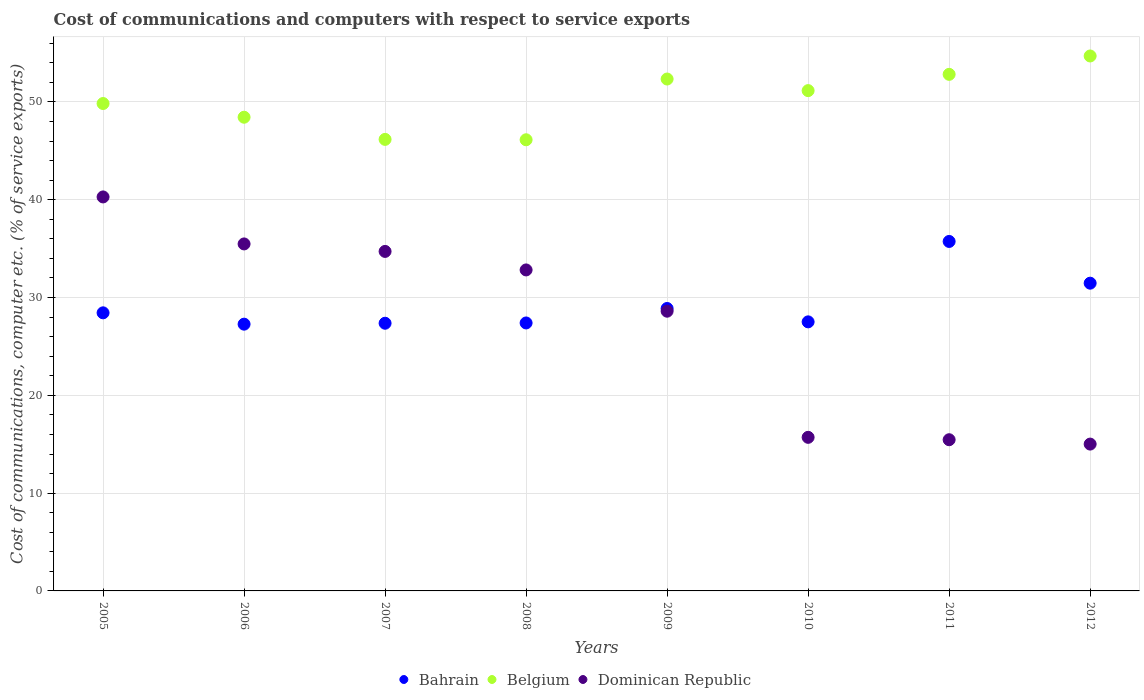How many different coloured dotlines are there?
Keep it short and to the point. 3. Is the number of dotlines equal to the number of legend labels?
Provide a succinct answer. Yes. What is the cost of communications and computers in Belgium in 2009?
Your answer should be very brief. 52.34. Across all years, what is the maximum cost of communications and computers in Bahrain?
Provide a succinct answer. 35.73. Across all years, what is the minimum cost of communications and computers in Dominican Republic?
Give a very brief answer. 15.01. What is the total cost of communications and computers in Bahrain in the graph?
Offer a terse response. 234.07. What is the difference between the cost of communications and computers in Belgium in 2007 and that in 2011?
Keep it short and to the point. -6.65. What is the difference between the cost of communications and computers in Bahrain in 2005 and the cost of communications and computers in Belgium in 2008?
Give a very brief answer. -17.7. What is the average cost of communications and computers in Belgium per year?
Offer a very short reply. 50.2. In the year 2007, what is the difference between the cost of communications and computers in Dominican Republic and cost of communications and computers in Bahrain?
Offer a very short reply. 7.34. What is the ratio of the cost of communications and computers in Bahrain in 2009 to that in 2010?
Offer a very short reply. 1.05. Is the difference between the cost of communications and computers in Dominican Republic in 2006 and 2008 greater than the difference between the cost of communications and computers in Bahrain in 2006 and 2008?
Your answer should be very brief. Yes. What is the difference between the highest and the second highest cost of communications and computers in Bahrain?
Your response must be concise. 4.27. What is the difference between the highest and the lowest cost of communications and computers in Belgium?
Ensure brevity in your answer.  8.57. In how many years, is the cost of communications and computers in Bahrain greater than the average cost of communications and computers in Bahrain taken over all years?
Provide a short and direct response. 2. Does the cost of communications and computers in Dominican Republic monotonically increase over the years?
Offer a very short reply. No. Is the cost of communications and computers in Bahrain strictly greater than the cost of communications and computers in Dominican Republic over the years?
Make the answer very short. No. How many years are there in the graph?
Give a very brief answer. 8. What is the difference between two consecutive major ticks on the Y-axis?
Offer a terse response. 10. Are the values on the major ticks of Y-axis written in scientific E-notation?
Your answer should be very brief. No. Does the graph contain any zero values?
Make the answer very short. No. Where does the legend appear in the graph?
Provide a short and direct response. Bottom center. How are the legend labels stacked?
Your answer should be very brief. Horizontal. What is the title of the graph?
Provide a succinct answer. Cost of communications and computers with respect to service exports. What is the label or title of the X-axis?
Offer a terse response. Years. What is the label or title of the Y-axis?
Offer a very short reply. Cost of communications, computer etc. (% of service exports). What is the Cost of communications, computer etc. (% of service exports) in Bahrain in 2005?
Give a very brief answer. 28.43. What is the Cost of communications, computer etc. (% of service exports) of Belgium in 2005?
Give a very brief answer. 49.84. What is the Cost of communications, computer etc. (% of service exports) in Dominican Republic in 2005?
Give a very brief answer. 40.28. What is the Cost of communications, computer etc. (% of service exports) in Bahrain in 2006?
Offer a terse response. 27.28. What is the Cost of communications, computer etc. (% of service exports) of Belgium in 2006?
Your answer should be very brief. 48.43. What is the Cost of communications, computer etc. (% of service exports) in Dominican Republic in 2006?
Ensure brevity in your answer.  35.48. What is the Cost of communications, computer etc. (% of service exports) of Bahrain in 2007?
Make the answer very short. 27.37. What is the Cost of communications, computer etc. (% of service exports) in Belgium in 2007?
Your answer should be compact. 46.17. What is the Cost of communications, computer etc. (% of service exports) of Dominican Republic in 2007?
Offer a very short reply. 34.71. What is the Cost of communications, computer etc. (% of service exports) of Bahrain in 2008?
Give a very brief answer. 27.4. What is the Cost of communications, computer etc. (% of service exports) in Belgium in 2008?
Offer a very short reply. 46.13. What is the Cost of communications, computer etc. (% of service exports) of Dominican Republic in 2008?
Give a very brief answer. 32.82. What is the Cost of communications, computer etc. (% of service exports) in Bahrain in 2009?
Provide a succinct answer. 28.88. What is the Cost of communications, computer etc. (% of service exports) in Belgium in 2009?
Your answer should be compact. 52.34. What is the Cost of communications, computer etc. (% of service exports) in Dominican Republic in 2009?
Give a very brief answer. 28.6. What is the Cost of communications, computer etc. (% of service exports) of Bahrain in 2010?
Provide a short and direct response. 27.51. What is the Cost of communications, computer etc. (% of service exports) of Belgium in 2010?
Ensure brevity in your answer.  51.16. What is the Cost of communications, computer etc. (% of service exports) in Dominican Republic in 2010?
Offer a very short reply. 15.7. What is the Cost of communications, computer etc. (% of service exports) of Bahrain in 2011?
Your answer should be very brief. 35.73. What is the Cost of communications, computer etc. (% of service exports) of Belgium in 2011?
Provide a short and direct response. 52.82. What is the Cost of communications, computer etc. (% of service exports) of Dominican Republic in 2011?
Give a very brief answer. 15.46. What is the Cost of communications, computer etc. (% of service exports) in Bahrain in 2012?
Offer a very short reply. 31.47. What is the Cost of communications, computer etc. (% of service exports) in Belgium in 2012?
Give a very brief answer. 54.7. What is the Cost of communications, computer etc. (% of service exports) in Dominican Republic in 2012?
Your response must be concise. 15.01. Across all years, what is the maximum Cost of communications, computer etc. (% of service exports) in Bahrain?
Offer a terse response. 35.73. Across all years, what is the maximum Cost of communications, computer etc. (% of service exports) of Belgium?
Offer a terse response. 54.7. Across all years, what is the maximum Cost of communications, computer etc. (% of service exports) of Dominican Republic?
Provide a short and direct response. 40.28. Across all years, what is the minimum Cost of communications, computer etc. (% of service exports) in Bahrain?
Make the answer very short. 27.28. Across all years, what is the minimum Cost of communications, computer etc. (% of service exports) in Belgium?
Offer a very short reply. 46.13. Across all years, what is the minimum Cost of communications, computer etc. (% of service exports) in Dominican Republic?
Your answer should be very brief. 15.01. What is the total Cost of communications, computer etc. (% of service exports) in Bahrain in the graph?
Provide a short and direct response. 234.07. What is the total Cost of communications, computer etc. (% of service exports) of Belgium in the graph?
Provide a short and direct response. 401.58. What is the total Cost of communications, computer etc. (% of service exports) of Dominican Republic in the graph?
Your answer should be compact. 218.08. What is the difference between the Cost of communications, computer etc. (% of service exports) of Bahrain in 2005 and that in 2006?
Provide a succinct answer. 1.16. What is the difference between the Cost of communications, computer etc. (% of service exports) of Belgium in 2005 and that in 2006?
Ensure brevity in your answer.  1.4. What is the difference between the Cost of communications, computer etc. (% of service exports) of Dominican Republic in 2005 and that in 2006?
Provide a succinct answer. 4.81. What is the difference between the Cost of communications, computer etc. (% of service exports) in Bahrain in 2005 and that in 2007?
Give a very brief answer. 1.06. What is the difference between the Cost of communications, computer etc. (% of service exports) of Belgium in 2005 and that in 2007?
Your answer should be compact. 3.67. What is the difference between the Cost of communications, computer etc. (% of service exports) in Dominican Republic in 2005 and that in 2007?
Your answer should be compact. 5.57. What is the difference between the Cost of communications, computer etc. (% of service exports) of Bahrain in 2005 and that in 2008?
Keep it short and to the point. 1.03. What is the difference between the Cost of communications, computer etc. (% of service exports) in Belgium in 2005 and that in 2008?
Provide a succinct answer. 3.71. What is the difference between the Cost of communications, computer etc. (% of service exports) of Dominican Republic in 2005 and that in 2008?
Provide a short and direct response. 7.46. What is the difference between the Cost of communications, computer etc. (% of service exports) in Bahrain in 2005 and that in 2009?
Make the answer very short. -0.44. What is the difference between the Cost of communications, computer etc. (% of service exports) of Belgium in 2005 and that in 2009?
Give a very brief answer. -2.5. What is the difference between the Cost of communications, computer etc. (% of service exports) of Dominican Republic in 2005 and that in 2009?
Offer a very short reply. 11.68. What is the difference between the Cost of communications, computer etc. (% of service exports) in Bahrain in 2005 and that in 2010?
Your response must be concise. 0.92. What is the difference between the Cost of communications, computer etc. (% of service exports) of Belgium in 2005 and that in 2010?
Provide a succinct answer. -1.32. What is the difference between the Cost of communications, computer etc. (% of service exports) in Dominican Republic in 2005 and that in 2010?
Provide a short and direct response. 24.58. What is the difference between the Cost of communications, computer etc. (% of service exports) in Bahrain in 2005 and that in 2011?
Provide a succinct answer. -7.3. What is the difference between the Cost of communications, computer etc. (% of service exports) in Belgium in 2005 and that in 2011?
Provide a succinct answer. -2.98. What is the difference between the Cost of communications, computer etc. (% of service exports) of Dominican Republic in 2005 and that in 2011?
Your answer should be compact. 24.82. What is the difference between the Cost of communications, computer etc. (% of service exports) of Bahrain in 2005 and that in 2012?
Keep it short and to the point. -3.03. What is the difference between the Cost of communications, computer etc. (% of service exports) in Belgium in 2005 and that in 2012?
Offer a very short reply. -4.86. What is the difference between the Cost of communications, computer etc. (% of service exports) of Dominican Republic in 2005 and that in 2012?
Offer a very short reply. 25.27. What is the difference between the Cost of communications, computer etc. (% of service exports) in Bahrain in 2006 and that in 2007?
Provide a short and direct response. -0.09. What is the difference between the Cost of communications, computer etc. (% of service exports) in Belgium in 2006 and that in 2007?
Your answer should be very brief. 2.27. What is the difference between the Cost of communications, computer etc. (% of service exports) in Dominican Republic in 2006 and that in 2007?
Keep it short and to the point. 0.77. What is the difference between the Cost of communications, computer etc. (% of service exports) of Bahrain in 2006 and that in 2008?
Your answer should be very brief. -0.12. What is the difference between the Cost of communications, computer etc. (% of service exports) in Belgium in 2006 and that in 2008?
Keep it short and to the point. 2.3. What is the difference between the Cost of communications, computer etc. (% of service exports) in Dominican Republic in 2006 and that in 2008?
Offer a terse response. 2.66. What is the difference between the Cost of communications, computer etc. (% of service exports) in Bahrain in 2006 and that in 2009?
Keep it short and to the point. -1.6. What is the difference between the Cost of communications, computer etc. (% of service exports) in Belgium in 2006 and that in 2009?
Give a very brief answer. -3.91. What is the difference between the Cost of communications, computer etc. (% of service exports) in Dominican Republic in 2006 and that in 2009?
Your response must be concise. 6.88. What is the difference between the Cost of communications, computer etc. (% of service exports) in Bahrain in 2006 and that in 2010?
Offer a terse response. -0.24. What is the difference between the Cost of communications, computer etc. (% of service exports) in Belgium in 2006 and that in 2010?
Give a very brief answer. -2.72. What is the difference between the Cost of communications, computer etc. (% of service exports) of Dominican Republic in 2006 and that in 2010?
Provide a succinct answer. 19.78. What is the difference between the Cost of communications, computer etc. (% of service exports) of Bahrain in 2006 and that in 2011?
Give a very brief answer. -8.46. What is the difference between the Cost of communications, computer etc. (% of service exports) of Belgium in 2006 and that in 2011?
Offer a terse response. -4.38. What is the difference between the Cost of communications, computer etc. (% of service exports) in Dominican Republic in 2006 and that in 2011?
Your answer should be compact. 20.02. What is the difference between the Cost of communications, computer etc. (% of service exports) in Bahrain in 2006 and that in 2012?
Your answer should be very brief. -4.19. What is the difference between the Cost of communications, computer etc. (% of service exports) in Belgium in 2006 and that in 2012?
Offer a very short reply. -6.26. What is the difference between the Cost of communications, computer etc. (% of service exports) in Dominican Republic in 2006 and that in 2012?
Provide a succinct answer. 20.47. What is the difference between the Cost of communications, computer etc. (% of service exports) of Bahrain in 2007 and that in 2008?
Provide a short and direct response. -0.03. What is the difference between the Cost of communications, computer etc. (% of service exports) in Belgium in 2007 and that in 2008?
Give a very brief answer. 0.04. What is the difference between the Cost of communications, computer etc. (% of service exports) of Dominican Republic in 2007 and that in 2008?
Provide a succinct answer. 1.89. What is the difference between the Cost of communications, computer etc. (% of service exports) of Bahrain in 2007 and that in 2009?
Make the answer very short. -1.51. What is the difference between the Cost of communications, computer etc. (% of service exports) in Belgium in 2007 and that in 2009?
Give a very brief answer. -6.17. What is the difference between the Cost of communications, computer etc. (% of service exports) in Dominican Republic in 2007 and that in 2009?
Provide a succinct answer. 6.11. What is the difference between the Cost of communications, computer etc. (% of service exports) in Bahrain in 2007 and that in 2010?
Make the answer very short. -0.14. What is the difference between the Cost of communications, computer etc. (% of service exports) of Belgium in 2007 and that in 2010?
Ensure brevity in your answer.  -4.99. What is the difference between the Cost of communications, computer etc. (% of service exports) of Dominican Republic in 2007 and that in 2010?
Offer a terse response. 19.01. What is the difference between the Cost of communications, computer etc. (% of service exports) of Bahrain in 2007 and that in 2011?
Your answer should be compact. -8.36. What is the difference between the Cost of communications, computer etc. (% of service exports) in Belgium in 2007 and that in 2011?
Keep it short and to the point. -6.65. What is the difference between the Cost of communications, computer etc. (% of service exports) of Dominican Republic in 2007 and that in 2011?
Offer a very short reply. 19.25. What is the difference between the Cost of communications, computer etc. (% of service exports) of Bahrain in 2007 and that in 2012?
Provide a succinct answer. -4.1. What is the difference between the Cost of communications, computer etc. (% of service exports) of Belgium in 2007 and that in 2012?
Provide a short and direct response. -8.53. What is the difference between the Cost of communications, computer etc. (% of service exports) of Dominican Republic in 2007 and that in 2012?
Ensure brevity in your answer.  19.7. What is the difference between the Cost of communications, computer etc. (% of service exports) of Bahrain in 2008 and that in 2009?
Your answer should be compact. -1.48. What is the difference between the Cost of communications, computer etc. (% of service exports) of Belgium in 2008 and that in 2009?
Ensure brevity in your answer.  -6.21. What is the difference between the Cost of communications, computer etc. (% of service exports) in Dominican Republic in 2008 and that in 2009?
Provide a succinct answer. 4.22. What is the difference between the Cost of communications, computer etc. (% of service exports) of Bahrain in 2008 and that in 2010?
Make the answer very short. -0.11. What is the difference between the Cost of communications, computer etc. (% of service exports) of Belgium in 2008 and that in 2010?
Provide a succinct answer. -5.03. What is the difference between the Cost of communications, computer etc. (% of service exports) in Dominican Republic in 2008 and that in 2010?
Your answer should be compact. 17.12. What is the difference between the Cost of communications, computer etc. (% of service exports) in Bahrain in 2008 and that in 2011?
Your answer should be very brief. -8.33. What is the difference between the Cost of communications, computer etc. (% of service exports) of Belgium in 2008 and that in 2011?
Keep it short and to the point. -6.69. What is the difference between the Cost of communications, computer etc. (% of service exports) in Dominican Republic in 2008 and that in 2011?
Your answer should be very brief. 17.36. What is the difference between the Cost of communications, computer etc. (% of service exports) of Bahrain in 2008 and that in 2012?
Your answer should be very brief. -4.07. What is the difference between the Cost of communications, computer etc. (% of service exports) in Belgium in 2008 and that in 2012?
Provide a succinct answer. -8.57. What is the difference between the Cost of communications, computer etc. (% of service exports) of Dominican Republic in 2008 and that in 2012?
Make the answer very short. 17.81. What is the difference between the Cost of communications, computer etc. (% of service exports) in Bahrain in 2009 and that in 2010?
Provide a short and direct response. 1.37. What is the difference between the Cost of communications, computer etc. (% of service exports) of Belgium in 2009 and that in 2010?
Your response must be concise. 1.19. What is the difference between the Cost of communications, computer etc. (% of service exports) of Dominican Republic in 2009 and that in 2010?
Keep it short and to the point. 12.9. What is the difference between the Cost of communications, computer etc. (% of service exports) of Bahrain in 2009 and that in 2011?
Keep it short and to the point. -6.85. What is the difference between the Cost of communications, computer etc. (% of service exports) of Belgium in 2009 and that in 2011?
Your response must be concise. -0.48. What is the difference between the Cost of communications, computer etc. (% of service exports) of Dominican Republic in 2009 and that in 2011?
Keep it short and to the point. 13.14. What is the difference between the Cost of communications, computer etc. (% of service exports) in Bahrain in 2009 and that in 2012?
Offer a very short reply. -2.59. What is the difference between the Cost of communications, computer etc. (% of service exports) in Belgium in 2009 and that in 2012?
Offer a terse response. -2.36. What is the difference between the Cost of communications, computer etc. (% of service exports) of Dominican Republic in 2009 and that in 2012?
Give a very brief answer. 13.59. What is the difference between the Cost of communications, computer etc. (% of service exports) in Bahrain in 2010 and that in 2011?
Give a very brief answer. -8.22. What is the difference between the Cost of communications, computer etc. (% of service exports) of Belgium in 2010 and that in 2011?
Ensure brevity in your answer.  -1.66. What is the difference between the Cost of communications, computer etc. (% of service exports) of Dominican Republic in 2010 and that in 2011?
Your response must be concise. 0.24. What is the difference between the Cost of communications, computer etc. (% of service exports) of Bahrain in 2010 and that in 2012?
Provide a succinct answer. -3.95. What is the difference between the Cost of communications, computer etc. (% of service exports) in Belgium in 2010 and that in 2012?
Keep it short and to the point. -3.54. What is the difference between the Cost of communications, computer etc. (% of service exports) in Dominican Republic in 2010 and that in 2012?
Provide a short and direct response. 0.69. What is the difference between the Cost of communications, computer etc. (% of service exports) of Bahrain in 2011 and that in 2012?
Make the answer very short. 4.27. What is the difference between the Cost of communications, computer etc. (% of service exports) of Belgium in 2011 and that in 2012?
Make the answer very short. -1.88. What is the difference between the Cost of communications, computer etc. (% of service exports) in Dominican Republic in 2011 and that in 2012?
Keep it short and to the point. 0.45. What is the difference between the Cost of communications, computer etc. (% of service exports) of Bahrain in 2005 and the Cost of communications, computer etc. (% of service exports) of Belgium in 2006?
Offer a terse response. -20. What is the difference between the Cost of communications, computer etc. (% of service exports) of Bahrain in 2005 and the Cost of communications, computer etc. (% of service exports) of Dominican Republic in 2006?
Your answer should be compact. -7.05. What is the difference between the Cost of communications, computer etc. (% of service exports) in Belgium in 2005 and the Cost of communications, computer etc. (% of service exports) in Dominican Republic in 2006?
Provide a succinct answer. 14.36. What is the difference between the Cost of communications, computer etc. (% of service exports) of Bahrain in 2005 and the Cost of communications, computer etc. (% of service exports) of Belgium in 2007?
Your response must be concise. -17.73. What is the difference between the Cost of communications, computer etc. (% of service exports) of Bahrain in 2005 and the Cost of communications, computer etc. (% of service exports) of Dominican Republic in 2007?
Your answer should be compact. -6.28. What is the difference between the Cost of communications, computer etc. (% of service exports) in Belgium in 2005 and the Cost of communications, computer etc. (% of service exports) in Dominican Republic in 2007?
Make the answer very short. 15.12. What is the difference between the Cost of communications, computer etc. (% of service exports) of Bahrain in 2005 and the Cost of communications, computer etc. (% of service exports) of Belgium in 2008?
Provide a short and direct response. -17.7. What is the difference between the Cost of communications, computer etc. (% of service exports) of Bahrain in 2005 and the Cost of communications, computer etc. (% of service exports) of Dominican Republic in 2008?
Your response must be concise. -4.39. What is the difference between the Cost of communications, computer etc. (% of service exports) of Belgium in 2005 and the Cost of communications, computer etc. (% of service exports) of Dominican Republic in 2008?
Your answer should be very brief. 17.02. What is the difference between the Cost of communications, computer etc. (% of service exports) in Bahrain in 2005 and the Cost of communications, computer etc. (% of service exports) in Belgium in 2009?
Keep it short and to the point. -23.91. What is the difference between the Cost of communications, computer etc. (% of service exports) in Bahrain in 2005 and the Cost of communications, computer etc. (% of service exports) in Dominican Republic in 2009?
Ensure brevity in your answer.  -0.17. What is the difference between the Cost of communications, computer etc. (% of service exports) of Belgium in 2005 and the Cost of communications, computer etc. (% of service exports) of Dominican Republic in 2009?
Offer a terse response. 21.24. What is the difference between the Cost of communications, computer etc. (% of service exports) in Bahrain in 2005 and the Cost of communications, computer etc. (% of service exports) in Belgium in 2010?
Make the answer very short. -22.72. What is the difference between the Cost of communications, computer etc. (% of service exports) in Bahrain in 2005 and the Cost of communications, computer etc. (% of service exports) in Dominican Republic in 2010?
Ensure brevity in your answer.  12.73. What is the difference between the Cost of communications, computer etc. (% of service exports) of Belgium in 2005 and the Cost of communications, computer etc. (% of service exports) of Dominican Republic in 2010?
Your response must be concise. 34.13. What is the difference between the Cost of communications, computer etc. (% of service exports) of Bahrain in 2005 and the Cost of communications, computer etc. (% of service exports) of Belgium in 2011?
Offer a terse response. -24.38. What is the difference between the Cost of communications, computer etc. (% of service exports) in Bahrain in 2005 and the Cost of communications, computer etc. (% of service exports) in Dominican Republic in 2011?
Provide a succinct answer. 12.97. What is the difference between the Cost of communications, computer etc. (% of service exports) of Belgium in 2005 and the Cost of communications, computer etc. (% of service exports) of Dominican Republic in 2011?
Make the answer very short. 34.38. What is the difference between the Cost of communications, computer etc. (% of service exports) in Bahrain in 2005 and the Cost of communications, computer etc. (% of service exports) in Belgium in 2012?
Keep it short and to the point. -26.26. What is the difference between the Cost of communications, computer etc. (% of service exports) in Bahrain in 2005 and the Cost of communications, computer etc. (% of service exports) in Dominican Republic in 2012?
Your answer should be compact. 13.42. What is the difference between the Cost of communications, computer etc. (% of service exports) in Belgium in 2005 and the Cost of communications, computer etc. (% of service exports) in Dominican Republic in 2012?
Give a very brief answer. 34.82. What is the difference between the Cost of communications, computer etc. (% of service exports) of Bahrain in 2006 and the Cost of communications, computer etc. (% of service exports) of Belgium in 2007?
Provide a succinct answer. -18.89. What is the difference between the Cost of communications, computer etc. (% of service exports) in Bahrain in 2006 and the Cost of communications, computer etc. (% of service exports) in Dominican Republic in 2007?
Make the answer very short. -7.44. What is the difference between the Cost of communications, computer etc. (% of service exports) of Belgium in 2006 and the Cost of communications, computer etc. (% of service exports) of Dominican Republic in 2007?
Provide a succinct answer. 13.72. What is the difference between the Cost of communications, computer etc. (% of service exports) in Bahrain in 2006 and the Cost of communications, computer etc. (% of service exports) in Belgium in 2008?
Offer a very short reply. -18.85. What is the difference between the Cost of communications, computer etc. (% of service exports) of Bahrain in 2006 and the Cost of communications, computer etc. (% of service exports) of Dominican Republic in 2008?
Your answer should be compact. -5.55. What is the difference between the Cost of communications, computer etc. (% of service exports) in Belgium in 2006 and the Cost of communications, computer etc. (% of service exports) in Dominican Republic in 2008?
Your answer should be very brief. 15.61. What is the difference between the Cost of communications, computer etc. (% of service exports) in Bahrain in 2006 and the Cost of communications, computer etc. (% of service exports) in Belgium in 2009?
Give a very brief answer. -25.07. What is the difference between the Cost of communications, computer etc. (% of service exports) of Bahrain in 2006 and the Cost of communications, computer etc. (% of service exports) of Dominican Republic in 2009?
Ensure brevity in your answer.  -1.33. What is the difference between the Cost of communications, computer etc. (% of service exports) in Belgium in 2006 and the Cost of communications, computer etc. (% of service exports) in Dominican Republic in 2009?
Make the answer very short. 19.83. What is the difference between the Cost of communications, computer etc. (% of service exports) of Bahrain in 2006 and the Cost of communications, computer etc. (% of service exports) of Belgium in 2010?
Offer a terse response. -23.88. What is the difference between the Cost of communications, computer etc. (% of service exports) of Bahrain in 2006 and the Cost of communications, computer etc. (% of service exports) of Dominican Republic in 2010?
Provide a short and direct response. 11.57. What is the difference between the Cost of communications, computer etc. (% of service exports) of Belgium in 2006 and the Cost of communications, computer etc. (% of service exports) of Dominican Republic in 2010?
Your answer should be very brief. 32.73. What is the difference between the Cost of communications, computer etc. (% of service exports) in Bahrain in 2006 and the Cost of communications, computer etc. (% of service exports) in Belgium in 2011?
Keep it short and to the point. -25.54. What is the difference between the Cost of communications, computer etc. (% of service exports) of Bahrain in 2006 and the Cost of communications, computer etc. (% of service exports) of Dominican Republic in 2011?
Your response must be concise. 11.82. What is the difference between the Cost of communications, computer etc. (% of service exports) in Belgium in 2006 and the Cost of communications, computer etc. (% of service exports) in Dominican Republic in 2011?
Ensure brevity in your answer.  32.97. What is the difference between the Cost of communications, computer etc. (% of service exports) in Bahrain in 2006 and the Cost of communications, computer etc. (% of service exports) in Belgium in 2012?
Keep it short and to the point. -27.42. What is the difference between the Cost of communications, computer etc. (% of service exports) of Bahrain in 2006 and the Cost of communications, computer etc. (% of service exports) of Dominican Republic in 2012?
Provide a short and direct response. 12.26. What is the difference between the Cost of communications, computer etc. (% of service exports) in Belgium in 2006 and the Cost of communications, computer etc. (% of service exports) in Dominican Republic in 2012?
Your answer should be compact. 33.42. What is the difference between the Cost of communications, computer etc. (% of service exports) of Bahrain in 2007 and the Cost of communications, computer etc. (% of service exports) of Belgium in 2008?
Keep it short and to the point. -18.76. What is the difference between the Cost of communications, computer etc. (% of service exports) of Bahrain in 2007 and the Cost of communications, computer etc. (% of service exports) of Dominican Republic in 2008?
Your answer should be compact. -5.45. What is the difference between the Cost of communications, computer etc. (% of service exports) in Belgium in 2007 and the Cost of communications, computer etc. (% of service exports) in Dominican Republic in 2008?
Your answer should be compact. 13.35. What is the difference between the Cost of communications, computer etc. (% of service exports) of Bahrain in 2007 and the Cost of communications, computer etc. (% of service exports) of Belgium in 2009?
Your response must be concise. -24.97. What is the difference between the Cost of communications, computer etc. (% of service exports) of Bahrain in 2007 and the Cost of communications, computer etc. (% of service exports) of Dominican Republic in 2009?
Your response must be concise. -1.23. What is the difference between the Cost of communications, computer etc. (% of service exports) in Belgium in 2007 and the Cost of communications, computer etc. (% of service exports) in Dominican Republic in 2009?
Your answer should be very brief. 17.57. What is the difference between the Cost of communications, computer etc. (% of service exports) in Bahrain in 2007 and the Cost of communications, computer etc. (% of service exports) in Belgium in 2010?
Your response must be concise. -23.79. What is the difference between the Cost of communications, computer etc. (% of service exports) in Bahrain in 2007 and the Cost of communications, computer etc. (% of service exports) in Dominican Republic in 2010?
Provide a succinct answer. 11.67. What is the difference between the Cost of communications, computer etc. (% of service exports) of Belgium in 2007 and the Cost of communications, computer etc. (% of service exports) of Dominican Republic in 2010?
Make the answer very short. 30.47. What is the difference between the Cost of communications, computer etc. (% of service exports) in Bahrain in 2007 and the Cost of communications, computer etc. (% of service exports) in Belgium in 2011?
Ensure brevity in your answer.  -25.45. What is the difference between the Cost of communications, computer etc. (% of service exports) in Bahrain in 2007 and the Cost of communications, computer etc. (% of service exports) in Dominican Republic in 2011?
Ensure brevity in your answer.  11.91. What is the difference between the Cost of communications, computer etc. (% of service exports) in Belgium in 2007 and the Cost of communications, computer etc. (% of service exports) in Dominican Republic in 2011?
Make the answer very short. 30.71. What is the difference between the Cost of communications, computer etc. (% of service exports) of Bahrain in 2007 and the Cost of communications, computer etc. (% of service exports) of Belgium in 2012?
Provide a succinct answer. -27.33. What is the difference between the Cost of communications, computer etc. (% of service exports) in Bahrain in 2007 and the Cost of communications, computer etc. (% of service exports) in Dominican Republic in 2012?
Provide a succinct answer. 12.36. What is the difference between the Cost of communications, computer etc. (% of service exports) of Belgium in 2007 and the Cost of communications, computer etc. (% of service exports) of Dominican Republic in 2012?
Offer a very short reply. 31.16. What is the difference between the Cost of communications, computer etc. (% of service exports) of Bahrain in 2008 and the Cost of communications, computer etc. (% of service exports) of Belgium in 2009?
Provide a succinct answer. -24.94. What is the difference between the Cost of communications, computer etc. (% of service exports) of Bahrain in 2008 and the Cost of communications, computer etc. (% of service exports) of Dominican Republic in 2009?
Offer a terse response. -1.2. What is the difference between the Cost of communications, computer etc. (% of service exports) in Belgium in 2008 and the Cost of communications, computer etc. (% of service exports) in Dominican Republic in 2009?
Ensure brevity in your answer.  17.53. What is the difference between the Cost of communications, computer etc. (% of service exports) of Bahrain in 2008 and the Cost of communications, computer etc. (% of service exports) of Belgium in 2010?
Your answer should be compact. -23.76. What is the difference between the Cost of communications, computer etc. (% of service exports) in Bahrain in 2008 and the Cost of communications, computer etc. (% of service exports) in Dominican Republic in 2010?
Ensure brevity in your answer.  11.7. What is the difference between the Cost of communications, computer etc. (% of service exports) in Belgium in 2008 and the Cost of communications, computer etc. (% of service exports) in Dominican Republic in 2010?
Make the answer very short. 30.43. What is the difference between the Cost of communications, computer etc. (% of service exports) in Bahrain in 2008 and the Cost of communications, computer etc. (% of service exports) in Belgium in 2011?
Your answer should be compact. -25.42. What is the difference between the Cost of communications, computer etc. (% of service exports) in Bahrain in 2008 and the Cost of communications, computer etc. (% of service exports) in Dominican Republic in 2011?
Ensure brevity in your answer.  11.94. What is the difference between the Cost of communications, computer etc. (% of service exports) of Belgium in 2008 and the Cost of communications, computer etc. (% of service exports) of Dominican Republic in 2011?
Provide a succinct answer. 30.67. What is the difference between the Cost of communications, computer etc. (% of service exports) in Bahrain in 2008 and the Cost of communications, computer etc. (% of service exports) in Belgium in 2012?
Your response must be concise. -27.3. What is the difference between the Cost of communications, computer etc. (% of service exports) in Bahrain in 2008 and the Cost of communications, computer etc. (% of service exports) in Dominican Republic in 2012?
Give a very brief answer. 12.39. What is the difference between the Cost of communications, computer etc. (% of service exports) in Belgium in 2008 and the Cost of communications, computer etc. (% of service exports) in Dominican Republic in 2012?
Your response must be concise. 31.12. What is the difference between the Cost of communications, computer etc. (% of service exports) of Bahrain in 2009 and the Cost of communications, computer etc. (% of service exports) of Belgium in 2010?
Make the answer very short. -22.28. What is the difference between the Cost of communications, computer etc. (% of service exports) of Bahrain in 2009 and the Cost of communications, computer etc. (% of service exports) of Dominican Republic in 2010?
Ensure brevity in your answer.  13.18. What is the difference between the Cost of communications, computer etc. (% of service exports) in Belgium in 2009 and the Cost of communications, computer etc. (% of service exports) in Dominican Republic in 2010?
Provide a succinct answer. 36.64. What is the difference between the Cost of communications, computer etc. (% of service exports) in Bahrain in 2009 and the Cost of communications, computer etc. (% of service exports) in Belgium in 2011?
Provide a succinct answer. -23.94. What is the difference between the Cost of communications, computer etc. (% of service exports) in Bahrain in 2009 and the Cost of communications, computer etc. (% of service exports) in Dominican Republic in 2011?
Make the answer very short. 13.42. What is the difference between the Cost of communications, computer etc. (% of service exports) of Belgium in 2009 and the Cost of communications, computer etc. (% of service exports) of Dominican Republic in 2011?
Provide a short and direct response. 36.88. What is the difference between the Cost of communications, computer etc. (% of service exports) in Bahrain in 2009 and the Cost of communications, computer etc. (% of service exports) in Belgium in 2012?
Your answer should be compact. -25.82. What is the difference between the Cost of communications, computer etc. (% of service exports) of Bahrain in 2009 and the Cost of communications, computer etc. (% of service exports) of Dominican Republic in 2012?
Provide a succinct answer. 13.87. What is the difference between the Cost of communications, computer etc. (% of service exports) in Belgium in 2009 and the Cost of communications, computer etc. (% of service exports) in Dominican Republic in 2012?
Provide a succinct answer. 37.33. What is the difference between the Cost of communications, computer etc. (% of service exports) of Bahrain in 2010 and the Cost of communications, computer etc. (% of service exports) of Belgium in 2011?
Ensure brevity in your answer.  -25.31. What is the difference between the Cost of communications, computer etc. (% of service exports) in Bahrain in 2010 and the Cost of communications, computer etc. (% of service exports) in Dominican Republic in 2011?
Provide a succinct answer. 12.05. What is the difference between the Cost of communications, computer etc. (% of service exports) in Belgium in 2010 and the Cost of communications, computer etc. (% of service exports) in Dominican Republic in 2011?
Offer a terse response. 35.7. What is the difference between the Cost of communications, computer etc. (% of service exports) in Bahrain in 2010 and the Cost of communications, computer etc. (% of service exports) in Belgium in 2012?
Ensure brevity in your answer.  -27.19. What is the difference between the Cost of communications, computer etc. (% of service exports) in Bahrain in 2010 and the Cost of communications, computer etc. (% of service exports) in Dominican Republic in 2012?
Ensure brevity in your answer.  12.5. What is the difference between the Cost of communications, computer etc. (% of service exports) in Belgium in 2010 and the Cost of communications, computer etc. (% of service exports) in Dominican Republic in 2012?
Your response must be concise. 36.14. What is the difference between the Cost of communications, computer etc. (% of service exports) of Bahrain in 2011 and the Cost of communications, computer etc. (% of service exports) of Belgium in 2012?
Give a very brief answer. -18.96. What is the difference between the Cost of communications, computer etc. (% of service exports) of Bahrain in 2011 and the Cost of communications, computer etc. (% of service exports) of Dominican Republic in 2012?
Keep it short and to the point. 20.72. What is the difference between the Cost of communications, computer etc. (% of service exports) in Belgium in 2011 and the Cost of communications, computer etc. (% of service exports) in Dominican Republic in 2012?
Give a very brief answer. 37.81. What is the average Cost of communications, computer etc. (% of service exports) of Bahrain per year?
Ensure brevity in your answer.  29.26. What is the average Cost of communications, computer etc. (% of service exports) in Belgium per year?
Provide a succinct answer. 50.2. What is the average Cost of communications, computer etc. (% of service exports) of Dominican Republic per year?
Ensure brevity in your answer.  27.26. In the year 2005, what is the difference between the Cost of communications, computer etc. (% of service exports) in Bahrain and Cost of communications, computer etc. (% of service exports) in Belgium?
Offer a very short reply. -21.4. In the year 2005, what is the difference between the Cost of communications, computer etc. (% of service exports) of Bahrain and Cost of communications, computer etc. (% of service exports) of Dominican Republic?
Provide a short and direct response. -11.85. In the year 2005, what is the difference between the Cost of communications, computer etc. (% of service exports) of Belgium and Cost of communications, computer etc. (% of service exports) of Dominican Republic?
Offer a terse response. 9.55. In the year 2006, what is the difference between the Cost of communications, computer etc. (% of service exports) in Bahrain and Cost of communications, computer etc. (% of service exports) in Belgium?
Keep it short and to the point. -21.16. In the year 2006, what is the difference between the Cost of communications, computer etc. (% of service exports) in Bahrain and Cost of communications, computer etc. (% of service exports) in Dominican Republic?
Your response must be concise. -8.2. In the year 2006, what is the difference between the Cost of communications, computer etc. (% of service exports) of Belgium and Cost of communications, computer etc. (% of service exports) of Dominican Republic?
Your answer should be very brief. 12.96. In the year 2007, what is the difference between the Cost of communications, computer etc. (% of service exports) of Bahrain and Cost of communications, computer etc. (% of service exports) of Belgium?
Make the answer very short. -18.8. In the year 2007, what is the difference between the Cost of communications, computer etc. (% of service exports) in Bahrain and Cost of communications, computer etc. (% of service exports) in Dominican Republic?
Offer a terse response. -7.34. In the year 2007, what is the difference between the Cost of communications, computer etc. (% of service exports) of Belgium and Cost of communications, computer etc. (% of service exports) of Dominican Republic?
Your answer should be very brief. 11.46. In the year 2008, what is the difference between the Cost of communications, computer etc. (% of service exports) of Bahrain and Cost of communications, computer etc. (% of service exports) of Belgium?
Keep it short and to the point. -18.73. In the year 2008, what is the difference between the Cost of communications, computer etc. (% of service exports) in Bahrain and Cost of communications, computer etc. (% of service exports) in Dominican Republic?
Give a very brief answer. -5.42. In the year 2008, what is the difference between the Cost of communications, computer etc. (% of service exports) of Belgium and Cost of communications, computer etc. (% of service exports) of Dominican Republic?
Offer a very short reply. 13.31. In the year 2009, what is the difference between the Cost of communications, computer etc. (% of service exports) in Bahrain and Cost of communications, computer etc. (% of service exports) in Belgium?
Provide a succinct answer. -23.46. In the year 2009, what is the difference between the Cost of communications, computer etc. (% of service exports) in Bahrain and Cost of communications, computer etc. (% of service exports) in Dominican Republic?
Offer a terse response. 0.28. In the year 2009, what is the difference between the Cost of communications, computer etc. (% of service exports) in Belgium and Cost of communications, computer etc. (% of service exports) in Dominican Republic?
Provide a succinct answer. 23.74. In the year 2010, what is the difference between the Cost of communications, computer etc. (% of service exports) of Bahrain and Cost of communications, computer etc. (% of service exports) of Belgium?
Give a very brief answer. -23.64. In the year 2010, what is the difference between the Cost of communications, computer etc. (% of service exports) of Bahrain and Cost of communications, computer etc. (% of service exports) of Dominican Republic?
Your answer should be compact. 11.81. In the year 2010, what is the difference between the Cost of communications, computer etc. (% of service exports) in Belgium and Cost of communications, computer etc. (% of service exports) in Dominican Republic?
Offer a very short reply. 35.45. In the year 2011, what is the difference between the Cost of communications, computer etc. (% of service exports) of Bahrain and Cost of communications, computer etc. (% of service exports) of Belgium?
Offer a very short reply. -17.09. In the year 2011, what is the difference between the Cost of communications, computer etc. (% of service exports) of Bahrain and Cost of communications, computer etc. (% of service exports) of Dominican Republic?
Your response must be concise. 20.27. In the year 2011, what is the difference between the Cost of communications, computer etc. (% of service exports) of Belgium and Cost of communications, computer etc. (% of service exports) of Dominican Republic?
Give a very brief answer. 37.36. In the year 2012, what is the difference between the Cost of communications, computer etc. (% of service exports) of Bahrain and Cost of communications, computer etc. (% of service exports) of Belgium?
Ensure brevity in your answer.  -23.23. In the year 2012, what is the difference between the Cost of communications, computer etc. (% of service exports) in Bahrain and Cost of communications, computer etc. (% of service exports) in Dominican Republic?
Your answer should be very brief. 16.45. In the year 2012, what is the difference between the Cost of communications, computer etc. (% of service exports) in Belgium and Cost of communications, computer etc. (% of service exports) in Dominican Republic?
Your answer should be compact. 39.68. What is the ratio of the Cost of communications, computer etc. (% of service exports) of Bahrain in 2005 to that in 2006?
Your answer should be very brief. 1.04. What is the ratio of the Cost of communications, computer etc. (% of service exports) of Belgium in 2005 to that in 2006?
Ensure brevity in your answer.  1.03. What is the ratio of the Cost of communications, computer etc. (% of service exports) in Dominican Republic in 2005 to that in 2006?
Make the answer very short. 1.14. What is the ratio of the Cost of communications, computer etc. (% of service exports) in Bahrain in 2005 to that in 2007?
Your answer should be very brief. 1.04. What is the ratio of the Cost of communications, computer etc. (% of service exports) of Belgium in 2005 to that in 2007?
Your answer should be compact. 1.08. What is the ratio of the Cost of communications, computer etc. (% of service exports) in Dominican Republic in 2005 to that in 2007?
Give a very brief answer. 1.16. What is the ratio of the Cost of communications, computer etc. (% of service exports) in Bahrain in 2005 to that in 2008?
Provide a succinct answer. 1.04. What is the ratio of the Cost of communications, computer etc. (% of service exports) in Belgium in 2005 to that in 2008?
Offer a very short reply. 1.08. What is the ratio of the Cost of communications, computer etc. (% of service exports) in Dominican Republic in 2005 to that in 2008?
Keep it short and to the point. 1.23. What is the ratio of the Cost of communications, computer etc. (% of service exports) in Bahrain in 2005 to that in 2009?
Your response must be concise. 0.98. What is the ratio of the Cost of communications, computer etc. (% of service exports) in Belgium in 2005 to that in 2009?
Your response must be concise. 0.95. What is the ratio of the Cost of communications, computer etc. (% of service exports) in Dominican Republic in 2005 to that in 2009?
Provide a succinct answer. 1.41. What is the ratio of the Cost of communications, computer etc. (% of service exports) in Bahrain in 2005 to that in 2010?
Keep it short and to the point. 1.03. What is the ratio of the Cost of communications, computer etc. (% of service exports) of Belgium in 2005 to that in 2010?
Provide a short and direct response. 0.97. What is the ratio of the Cost of communications, computer etc. (% of service exports) of Dominican Republic in 2005 to that in 2010?
Give a very brief answer. 2.57. What is the ratio of the Cost of communications, computer etc. (% of service exports) of Bahrain in 2005 to that in 2011?
Make the answer very short. 0.8. What is the ratio of the Cost of communications, computer etc. (% of service exports) of Belgium in 2005 to that in 2011?
Give a very brief answer. 0.94. What is the ratio of the Cost of communications, computer etc. (% of service exports) in Dominican Republic in 2005 to that in 2011?
Provide a succinct answer. 2.61. What is the ratio of the Cost of communications, computer etc. (% of service exports) in Bahrain in 2005 to that in 2012?
Your answer should be compact. 0.9. What is the ratio of the Cost of communications, computer etc. (% of service exports) of Belgium in 2005 to that in 2012?
Give a very brief answer. 0.91. What is the ratio of the Cost of communications, computer etc. (% of service exports) in Dominican Republic in 2005 to that in 2012?
Keep it short and to the point. 2.68. What is the ratio of the Cost of communications, computer etc. (% of service exports) of Belgium in 2006 to that in 2007?
Your answer should be very brief. 1.05. What is the ratio of the Cost of communications, computer etc. (% of service exports) in Dominican Republic in 2006 to that in 2007?
Provide a short and direct response. 1.02. What is the ratio of the Cost of communications, computer etc. (% of service exports) in Bahrain in 2006 to that in 2008?
Provide a short and direct response. 1. What is the ratio of the Cost of communications, computer etc. (% of service exports) in Dominican Republic in 2006 to that in 2008?
Keep it short and to the point. 1.08. What is the ratio of the Cost of communications, computer etc. (% of service exports) of Bahrain in 2006 to that in 2009?
Your answer should be very brief. 0.94. What is the ratio of the Cost of communications, computer etc. (% of service exports) in Belgium in 2006 to that in 2009?
Your answer should be very brief. 0.93. What is the ratio of the Cost of communications, computer etc. (% of service exports) in Dominican Republic in 2006 to that in 2009?
Your answer should be compact. 1.24. What is the ratio of the Cost of communications, computer etc. (% of service exports) in Belgium in 2006 to that in 2010?
Make the answer very short. 0.95. What is the ratio of the Cost of communications, computer etc. (% of service exports) of Dominican Republic in 2006 to that in 2010?
Provide a succinct answer. 2.26. What is the ratio of the Cost of communications, computer etc. (% of service exports) in Bahrain in 2006 to that in 2011?
Provide a succinct answer. 0.76. What is the ratio of the Cost of communications, computer etc. (% of service exports) of Belgium in 2006 to that in 2011?
Ensure brevity in your answer.  0.92. What is the ratio of the Cost of communications, computer etc. (% of service exports) of Dominican Republic in 2006 to that in 2011?
Your response must be concise. 2.29. What is the ratio of the Cost of communications, computer etc. (% of service exports) in Bahrain in 2006 to that in 2012?
Provide a short and direct response. 0.87. What is the ratio of the Cost of communications, computer etc. (% of service exports) of Belgium in 2006 to that in 2012?
Give a very brief answer. 0.89. What is the ratio of the Cost of communications, computer etc. (% of service exports) of Dominican Republic in 2006 to that in 2012?
Ensure brevity in your answer.  2.36. What is the ratio of the Cost of communications, computer etc. (% of service exports) of Dominican Republic in 2007 to that in 2008?
Make the answer very short. 1.06. What is the ratio of the Cost of communications, computer etc. (% of service exports) of Bahrain in 2007 to that in 2009?
Your response must be concise. 0.95. What is the ratio of the Cost of communications, computer etc. (% of service exports) of Belgium in 2007 to that in 2009?
Offer a very short reply. 0.88. What is the ratio of the Cost of communications, computer etc. (% of service exports) of Dominican Republic in 2007 to that in 2009?
Provide a succinct answer. 1.21. What is the ratio of the Cost of communications, computer etc. (% of service exports) of Belgium in 2007 to that in 2010?
Your response must be concise. 0.9. What is the ratio of the Cost of communications, computer etc. (% of service exports) in Dominican Republic in 2007 to that in 2010?
Your answer should be very brief. 2.21. What is the ratio of the Cost of communications, computer etc. (% of service exports) in Bahrain in 2007 to that in 2011?
Your answer should be very brief. 0.77. What is the ratio of the Cost of communications, computer etc. (% of service exports) in Belgium in 2007 to that in 2011?
Ensure brevity in your answer.  0.87. What is the ratio of the Cost of communications, computer etc. (% of service exports) of Dominican Republic in 2007 to that in 2011?
Offer a terse response. 2.25. What is the ratio of the Cost of communications, computer etc. (% of service exports) in Bahrain in 2007 to that in 2012?
Your response must be concise. 0.87. What is the ratio of the Cost of communications, computer etc. (% of service exports) in Belgium in 2007 to that in 2012?
Provide a short and direct response. 0.84. What is the ratio of the Cost of communications, computer etc. (% of service exports) of Dominican Republic in 2007 to that in 2012?
Your answer should be very brief. 2.31. What is the ratio of the Cost of communications, computer etc. (% of service exports) in Bahrain in 2008 to that in 2009?
Make the answer very short. 0.95. What is the ratio of the Cost of communications, computer etc. (% of service exports) in Belgium in 2008 to that in 2009?
Offer a very short reply. 0.88. What is the ratio of the Cost of communications, computer etc. (% of service exports) of Dominican Republic in 2008 to that in 2009?
Provide a short and direct response. 1.15. What is the ratio of the Cost of communications, computer etc. (% of service exports) of Belgium in 2008 to that in 2010?
Offer a terse response. 0.9. What is the ratio of the Cost of communications, computer etc. (% of service exports) of Dominican Republic in 2008 to that in 2010?
Provide a succinct answer. 2.09. What is the ratio of the Cost of communications, computer etc. (% of service exports) in Bahrain in 2008 to that in 2011?
Your answer should be compact. 0.77. What is the ratio of the Cost of communications, computer etc. (% of service exports) in Belgium in 2008 to that in 2011?
Provide a short and direct response. 0.87. What is the ratio of the Cost of communications, computer etc. (% of service exports) in Dominican Republic in 2008 to that in 2011?
Make the answer very short. 2.12. What is the ratio of the Cost of communications, computer etc. (% of service exports) of Bahrain in 2008 to that in 2012?
Provide a succinct answer. 0.87. What is the ratio of the Cost of communications, computer etc. (% of service exports) in Belgium in 2008 to that in 2012?
Give a very brief answer. 0.84. What is the ratio of the Cost of communications, computer etc. (% of service exports) of Dominican Republic in 2008 to that in 2012?
Your answer should be very brief. 2.19. What is the ratio of the Cost of communications, computer etc. (% of service exports) of Bahrain in 2009 to that in 2010?
Make the answer very short. 1.05. What is the ratio of the Cost of communications, computer etc. (% of service exports) in Belgium in 2009 to that in 2010?
Provide a short and direct response. 1.02. What is the ratio of the Cost of communications, computer etc. (% of service exports) of Dominican Republic in 2009 to that in 2010?
Ensure brevity in your answer.  1.82. What is the ratio of the Cost of communications, computer etc. (% of service exports) of Bahrain in 2009 to that in 2011?
Your answer should be compact. 0.81. What is the ratio of the Cost of communications, computer etc. (% of service exports) in Dominican Republic in 2009 to that in 2011?
Your answer should be compact. 1.85. What is the ratio of the Cost of communications, computer etc. (% of service exports) in Bahrain in 2009 to that in 2012?
Give a very brief answer. 0.92. What is the ratio of the Cost of communications, computer etc. (% of service exports) in Belgium in 2009 to that in 2012?
Provide a succinct answer. 0.96. What is the ratio of the Cost of communications, computer etc. (% of service exports) of Dominican Republic in 2009 to that in 2012?
Offer a very short reply. 1.91. What is the ratio of the Cost of communications, computer etc. (% of service exports) in Bahrain in 2010 to that in 2011?
Ensure brevity in your answer.  0.77. What is the ratio of the Cost of communications, computer etc. (% of service exports) of Belgium in 2010 to that in 2011?
Offer a very short reply. 0.97. What is the ratio of the Cost of communications, computer etc. (% of service exports) of Dominican Republic in 2010 to that in 2011?
Provide a short and direct response. 1.02. What is the ratio of the Cost of communications, computer etc. (% of service exports) in Bahrain in 2010 to that in 2012?
Offer a terse response. 0.87. What is the ratio of the Cost of communications, computer etc. (% of service exports) of Belgium in 2010 to that in 2012?
Ensure brevity in your answer.  0.94. What is the ratio of the Cost of communications, computer etc. (% of service exports) in Dominican Republic in 2010 to that in 2012?
Provide a short and direct response. 1.05. What is the ratio of the Cost of communications, computer etc. (% of service exports) in Bahrain in 2011 to that in 2012?
Your answer should be very brief. 1.14. What is the ratio of the Cost of communications, computer etc. (% of service exports) of Belgium in 2011 to that in 2012?
Keep it short and to the point. 0.97. What is the ratio of the Cost of communications, computer etc. (% of service exports) in Dominican Republic in 2011 to that in 2012?
Offer a terse response. 1.03. What is the difference between the highest and the second highest Cost of communications, computer etc. (% of service exports) of Bahrain?
Keep it short and to the point. 4.27. What is the difference between the highest and the second highest Cost of communications, computer etc. (% of service exports) of Belgium?
Provide a short and direct response. 1.88. What is the difference between the highest and the second highest Cost of communications, computer etc. (% of service exports) in Dominican Republic?
Provide a succinct answer. 4.81. What is the difference between the highest and the lowest Cost of communications, computer etc. (% of service exports) of Bahrain?
Provide a succinct answer. 8.46. What is the difference between the highest and the lowest Cost of communications, computer etc. (% of service exports) of Belgium?
Provide a succinct answer. 8.57. What is the difference between the highest and the lowest Cost of communications, computer etc. (% of service exports) of Dominican Republic?
Provide a short and direct response. 25.27. 